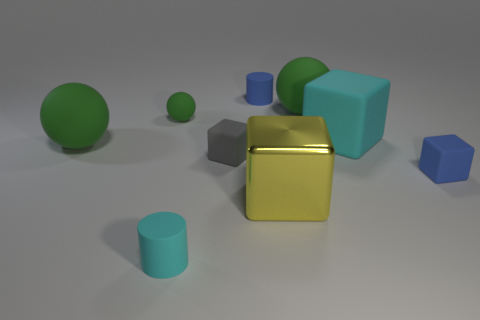Subtract all green spheres. How many were subtracted if there are1green spheres left? 2 Add 1 rubber cylinders. How many objects exist? 10 Subtract all cylinders. How many objects are left? 7 Add 5 purple matte blocks. How many purple matte blocks exist? 5 Subtract 0 purple cylinders. How many objects are left? 9 Subtract all brown shiny cylinders. Subtract all tiny green matte things. How many objects are left? 8 Add 3 gray blocks. How many gray blocks are left? 4 